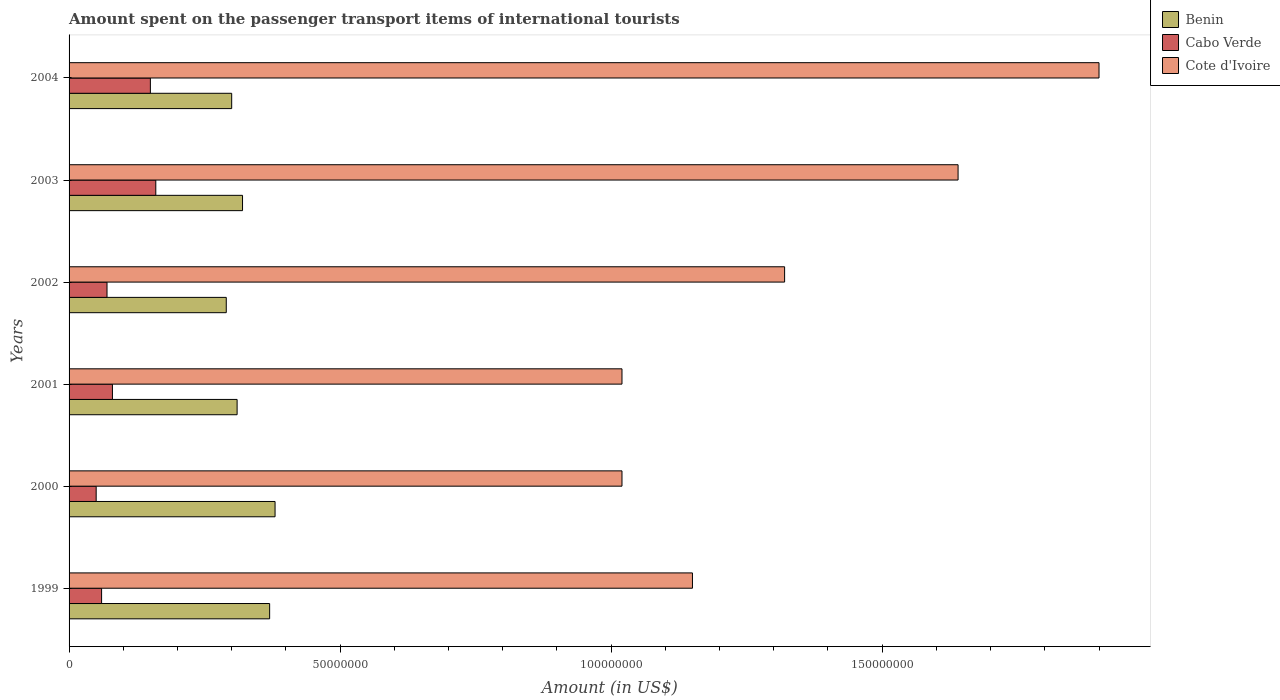Are the number of bars on each tick of the Y-axis equal?
Your answer should be compact. Yes. How many bars are there on the 4th tick from the top?
Provide a succinct answer. 3. What is the label of the 3rd group of bars from the top?
Your answer should be compact. 2002. What is the amount spent on the passenger transport items of international tourists in Cabo Verde in 2003?
Offer a terse response. 1.60e+07. Across all years, what is the maximum amount spent on the passenger transport items of international tourists in Cote d'Ivoire?
Give a very brief answer. 1.90e+08. Across all years, what is the minimum amount spent on the passenger transport items of international tourists in Cote d'Ivoire?
Provide a short and direct response. 1.02e+08. What is the total amount spent on the passenger transport items of international tourists in Cote d'Ivoire in the graph?
Your answer should be very brief. 8.05e+08. What is the difference between the amount spent on the passenger transport items of international tourists in Cabo Verde in 2002 and that in 2004?
Make the answer very short. -8.00e+06. What is the difference between the amount spent on the passenger transport items of international tourists in Cote d'Ivoire in 1999 and the amount spent on the passenger transport items of international tourists in Benin in 2003?
Offer a very short reply. 8.30e+07. What is the average amount spent on the passenger transport items of international tourists in Cote d'Ivoire per year?
Give a very brief answer. 1.34e+08. In the year 2000, what is the difference between the amount spent on the passenger transport items of international tourists in Benin and amount spent on the passenger transport items of international tourists in Cote d'Ivoire?
Keep it short and to the point. -6.40e+07. What is the ratio of the amount spent on the passenger transport items of international tourists in Cote d'Ivoire in 2001 to that in 2002?
Give a very brief answer. 0.77. Is the difference between the amount spent on the passenger transport items of international tourists in Benin in 2002 and 2003 greater than the difference between the amount spent on the passenger transport items of international tourists in Cote d'Ivoire in 2002 and 2003?
Keep it short and to the point. Yes. What is the difference between the highest and the lowest amount spent on the passenger transport items of international tourists in Cabo Verde?
Offer a terse response. 1.10e+07. What does the 2nd bar from the top in 1999 represents?
Ensure brevity in your answer.  Cabo Verde. What does the 3rd bar from the bottom in 2001 represents?
Make the answer very short. Cote d'Ivoire. How many bars are there?
Keep it short and to the point. 18. Are all the bars in the graph horizontal?
Offer a terse response. Yes. Are the values on the major ticks of X-axis written in scientific E-notation?
Your answer should be very brief. No. Where does the legend appear in the graph?
Keep it short and to the point. Top right. How many legend labels are there?
Make the answer very short. 3. What is the title of the graph?
Provide a succinct answer. Amount spent on the passenger transport items of international tourists. What is the label or title of the Y-axis?
Give a very brief answer. Years. What is the Amount (in US$) in Benin in 1999?
Provide a short and direct response. 3.70e+07. What is the Amount (in US$) of Cote d'Ivoire in 1999?
Your answer should be compact. 1.15e+08. What is the Amount (in US$) in Benin in 2000?
Make the answer very short. 3.80e+07. What is the Amount (in US$) in Cabo Verde in 2000?
Ensure brevity in your answer.  5.00e+06. What is the Amount (in US$) of Cote d'Ivoire in 2000?
Your answer should be compact. 1.02e+08. What is the Amount (in US$) in Benin in 2001?
Provide a short and direct response. 3.10e+07. What is the Amount (in US$) in Cabo Verde in 2001?
Make the answer very short. 8.00e+06. What is the Amount (in US$) in Cote d'Ivoire in 2001?
Make the answer very short. 1.02e+08. What is the Amount (in US$) of Benin in 2002?
Your answer should be compact. 2.90e+07. What is the Amount (in US$) in Cabo Verde in 2002?
Your response must be concise. 7.00e+06. What is the Amount (in US$) in Cote d'Ivoire in 2002?
Provide a short and direct response. 1.32e+08. What is the Amount (in US$) of Benin in 2003?
Give a very brief answer. 3.20e+07. What is the Amount (in US$) in Cabo Verde in 2003?
Provide a succinct answer. 1.60e+07. What is the Amount (in US$) of Cote d'Ivoire in 2003?
Offer a terse response. 1.64e+08. What is the Amount (in US$) of Benin in 2004?
Offer a very short reply. 3.00e+07. What is the Amount (in US$) of Cabo Verde in 2004?
Offer a very short reply. 1.50e+07. What is the Amount (in US$) in Cote d'Ivoire in 2004?
Your response must be concise. 1.90e+08. Across all years, what is the maximum Amount (in US$) in Benin?
Provide a succinct answer. 3.80e+07. Across all years, what is the maximum Amount (in US$) in Cabo Verde?
Ensure brevity in your answer.  1.60e+07. Across all years, what is the maximum Amount (in US$) of Cote d'Ivoire?
Make the answer very short. 1.90e+08. Across all years, what is the minimum Amount (in US$) of Benin?
Offer a very short reply. 2.90e+07. Across all years, what is the minimum Amount (in US$) in Cote d'Ivoire?
Your response must be concise. 1.02e+08. What is the total Amount (in US$) in Benin in the graph?
Make the answer very short. 1.97e+08. What is the total Amount (in US$) in Cabo Verde in the graph?
Keep it short and to the point. 5.70e+07. What is the total Amount (in US$) of Cote d'Ivoire in the graph?
Keep it short and to the point. 8.05e+08. What is the difference between the Amount (in US$) of Cote d'Ivoire in 1999 and that in 2000?
Provide a succinct answer. 1.30e+07. What is the difference between the Amount (in US$) of Cote d'Ivoire in 1999 and that in 2001?
Your answer should be compact. 1.30e+07. What is the difference between the Amount (in US$) of Benin in 1999 and that in 2002?
Your answer should be compact. 8.00e+06. What is the difference between the Amount (in US$) of Cabo Verde in 1999 and that in 2002?
Provide a succinct answer. -1.00e+06. What is the difference between the Amount (in US$) in Cote d'Ivoire in 1999 and that in 2002?
Your response must be concise. -1.70e+07. What is the difference between the Amount (in US$) of Cabo Verde in 1999 and that in 2003?
Ensure brevity in your answer.  -1.00e+07. What is the difference between the Amount (in US$) of Cote d'Ivoire in 1999 and that in 2003?
Give a very brief answer. -4.90e+07. What is the difference between the Amount (in US$) in Benin in 1999 and that in 2004?
Your response must be concise. 7.00e+06. What is the difference between the Amount (in US$) in Cabo Verde in 1999 and that in 2004?
Offer a terse response. -9.00e+06. What is the difference between the Amount (in US$) in Cote d'Ivoire in 1999 and that in 2004?
Provide a succinct answer. -7.50e+07. What is the difference between the Amount (in US$) of Cabo Verde in 2000 and that in 2001?
Your answer should be compact. -3.00e+06. What is the difference between the Amount (in US$) of Cote d'Ivoire in 2000 and that in 2001?
Provide a short and direct response. 0. What is the difference between the Amount (in US$) in Benin in 2000 and that in 2002?
Offer a terse response. 9.00e+06. What is the difference between the Amount (in US$) of Cabo Verde in 2000 and that in 2002?
Make the answer very short. -2.00e+06. What is the difference between the Amount (in US$) in Cote d'Ivoire in 2000 and that in 2002?
Give a very brief answer. -3.00e+07. What is the difference between the Amount (in US$) of Cabo Verde in 2000 and that in 2003?
Provide a succinct answer. -1.10e+07. What is the difference between the Amount (in US$) in Cote d'Ivoire in 2000 and that in 2003?
Offer a very short reply. -6.20e+07. What is the difference between the Amount (in US$) of Benin in 2000 and that in 2004?
Your answer should be compact. 8.00e+06. What is the difference between the Amount (in US$) in Cabo Verde in 2000 and that in 2004?
Offer a very short reply. -1.00e+07. What is the difference between the Amount (in US$) in Cote d'Ivoire in 2000 and that in 2004?
Your answer should be compact. -8.80e+07. What is the difference between the Amount (in US$) in Cote d'Ivoire in 2001 and that in 2002?
Make the answer very short. -3.00e+07. What is the difference between the Amount (in US$) in Cabo Verde in 2001 and that in 2003?
Offer a very short reply. -8.00e+06. What is the difference between the Amount (in US$) of Cote d'Ivoire in 2001 and that in 2003?
Give a very brief answer. -6.20e+07. What is the difference between the Amount (in US$) of Cabo Verde in 2001 and that in 2004?
Give a very brief answer. -7.00e+06. What is the difference between the Amount (in US$) in Cote d'Ivoire in 2001 and that in 2004?
Make the answer very short. -8.80e+07. What is the difference between the Amount (in US$) in Cabo Verde in 2002 and that in 2003?
Provide a succinct answer. -9.00e+06. What is the difference between the Amount (in US$) in Cote d'Ivoire in 2002 and that in 2003?
Offer a very short reply. -3.20e+07. What is the difference between the Amount (in US$) of Cabo Verde in 2002 and that in 2004?
Ensure brevity in your answer.  -8.00e+06. What is the difference between the Amount (in US$) of Cote d'Ivoire in 2002 and that in 2004?
Your answer should be compact. -5.80e+07. What is the difference between the Amount (in US$) of Benin in 2003 and that in 2004?
Your response must be concise. 2.00e+06. What is the difference between the Amount (in US$) in Cabo Verde in 2003 and that in 2004?
Ensure brevity in your answer.  1.00e+06. What is the difference between the Amount (in US$) in Cote d'Ivoire in 2003 and that in 2004?
Ensure brevity in your answer.  -2.60e+07. What is the difference between the Amount (in US$) of Benin in 1999 and the Amount (in US$) of Cabo Verde in 2000?
Your response must be concise. 3.20e+07. What is the difference between the Amount (in US$) of Benin in 1999 and the Amount (in US$) of Cote d'Ivoire in 2000?
Your response must be concise. -6.50e+07. What is the difference between the Amount (in US$) of Cabo Verde in 1999 and the Amount (in US$) of Cote d'Ivoire in 2000?
Offer a very short reply. -9.60e+07. What is the difference between the Amount (in US$) in Benin in 1999 and the Amount (in US$) in Cabo Verde in 2001?
Your answer should be compact. 2.90e+07. What is the difference between the Amount (in US$) of Benin in 1999 and the Amount (in US$) of Cote d'Ivoire in 2001?
Your answer should be compact. -6.50e+07. What is the difference between the Amount (in US$) of Cabo Verde in 1999 and the Amount (in US$) of Cote d'Ivoire in 2001?
Your answer should be very brief. -9.60e+07. What is the difference between the Amount (in US$) of Benin in 1999 and the Amount (in US$) of Cabo Verde in 2002?
Keep it short and to the point. 3.00e+07. What is the difference between the Amount (in US$) in Benin in 1999 and the Amount (in US$) in Cote d'Ivoire in 2002?
Provide a succinct answer. -9.50e+07. What is the difference between the Amount (in US$) in Cabo Verde in 1999 and the Amount (in US$) in Cote d'Ivoire in 2002?
Give a very brief answer. -1.26e+08. What is the difference between the Amount (in US$) in Benin in 1999 and the Amount (in US$) in Cabo Verde in 2003?
Offer a terse response. 2.10e+07. What is the difference between the Amount (in US$) of Benin in 1999 and the Amount (in US$) of Cote d'Ivoire in 2003?
Provide a succinct answer. -1.27e+08. What is the difference between the Amount (in US$) of Cabo Verde in 1999 and the Amount (in US$) of Cote d'Ivoire in 2003?
Your answer should be very brief. -1.58e+08. What is the difference between the Amount (in US$) in Benin in 1999 and the Amount (in US$) in Cabo Verde in 2004?
Give a very brief answer. 2.20e+07. What is the difference between the Amount (in US$) of Benin in 1999 and the Amount (in US$) of Cote d'Ivoire in 2004?
Ensure brevity in your answer.  -1.53e+08. What is the difference between the Amount (in US$) of Cabo Verde in 1999 and the Amount (in US$) of Cote d'Ivoire in 2004?
Provide a short and direct response. -1.84e+08. What is the difference between the Amount (in US$) in Benin in 2000 and the Amount (in US$) in Cabo Verde in 2001?
Make the answer very short. 3.00e+07. What is the difference between the Amount (in US$) in Benin in 2000 and the Amount (in US$) in Cote d'Ivoire in 2001?
Your response must be concise. -6.40e+07. What is the difference between the Amount (in US$) in Cabo Verde in 2000 and the Amount (in US$) in Cote d'Ivoire in 2001?
Your answer should be compact. -9.70e+07. What is the difference between the Amount (in US$) in Benin in 2000 and the Amount (in US$) in Cabo Verde in 2002?
Your response must be concise. 3.10e+07. What is the difference between the Amount (in US$) in Benin in 2000 and the Amount (in US$) in Cote d'Ivoire in 2002?
Your answer should be compact. -9.40e+07. What is the difference between the Amount (in US$) of Cabo Verde in 2000 and the Amount (in US$) of Cote d'Ivoire in 2002?
Give a very brief answer. -1.27e+08. What is the difference between the Amount (in US$) in Benin in 2000 and the Amount (in US$) in Cabo Verde in 2003?
Make the answer very short. 2.20e+07. What is the difference between the Amount (in US$) of Benin in 2000 and the Amount (in US$) of Cote d'Ivoire in 2003?
Provide a short and direct response. -1.26e+08. What is the difference between the Amount (in US$) of Cabo Verde in 2000 and the Amount (in US$) of Cote d'Ivoire in 2003?
Your answer should be compact. -1.59e+08. What is the difference between the Amount (in US$) of Benin in 2000 and the Amount (in US$) of Cabo Verde in 2004?
Offer a very short reply. 2.30e+07. What is the difference between the Amount (in US$) of Benin in 2000 and the Amount (in US$) of Cote d'Ivoire in 2004?
Provide a short and direct response. -1.52e+08. What is the difference between the Amount (in US$) in Cabo Verde in 2000 and the Amount (in US$) in Cote d'Ivoire in 2004?
Your answer should be compact. -1.85e+08. What is the difference between the Amount (in US$) of Benin in 2001 and the Amount (in US$) of Cabo Verde in 2002?
Give a very brief answer. 2.40e+07. What is the difference between the Amount (in US$) in Benin in 2001 and the Amount (in US$) in Cote d'Ivoire in 2002?
Ensure brevity in your answer.  -1.01e+08. What is the difference between the Amount (in US$) of Cabo Verde in 2001 and the Amount (in US$) of Cote d'Ivoire in 2002?
Your answer should be compact. -1.24e+08. What is the difference between the Amount (in US$) of Benin in 2001 and the Amount (in US$) of Cabo Verde in 2003?
Offer a terse response. 1.50e+07. What is the difference between the Amount (in US$) of Benin in 2001 and the Amount (in US$) of Cote d'Ivoire in 2003?
Offer a very short reply. -1.33e+08. What is the difference between the Amount (in US$) in Cabo Verde in 2001 and the Amount (in US$) in Cote d'Ivoire in 2003?
Your response must be concise. -1.56e+08. What is the difference between the Amount (in US$) of Benin in 2001 and the Amount (in US$) of Cabo Verde in 2004?
Ensure brevity in your answer.  1.60e+07. What is the difference between the Amount (in US$) in Benin in 2001 and the Amount (in US$) in Cote d'Ivoire in 2004?
Offer a terse response. -1.59e+08. What is the difference between the Amount (in US$) of Cabo Verde in 2001 and the Amount (in US$) of Cote d'Ivoire in 2004?
Make the answer very short. -1.82e+08. What is the difference between the Amount (in US$) of Benin in 2002 and the Amount (in US$) of Cabo Verde in 2003?
Ensure brevity in your answer.  1.30e+07. What is the difference between the Amount (in US$) in Benin in 2002 and the Amount (in US$) in Cote d'Ivoire in 2003?
Ensure brevity in your answer.  -1.35e+08. What is the difference between the Amount (in US$) of Cabo Verde in 2002 and the Amount (in US$) of Cote d'Ivoire in 2003?
Your answer should be very brief. -1.57e+08. What is the difference between the Amount (in US$) in Benin in 2002 and the Amount (in US$) in Cabo Verde in 2004?
Give a very brief answer. 1.40e+07. What is the difference between the Amount (in US$) in Benin in 2002 and the Amount (in US$) in Cote d'Ivoire in 2004?
Offer a terse response. -1.61e+08. What is the difference between the Amount (in US$) of Cabo Verde in 2002 and the Amount (in US$) of Cote d'Ivoire in 2004?
Your answer should be very brief. -1.83e+08. What is the difference between the Amount (in US$) in Benin in 2003 and the Amount (in US$) in Cabo Verde in 2004?
Your answer should be compact. 1.70e+07. What is the difference between the Amount (in US$) in Benin in 2003 and the Amount (in US$) in Cote d'Ivoire in 2004?
Provide a short and direct response. -1.58e+08. What is the difference between the Amount (in US$) in Cabo Verde in 2003 and the Amount (in US$) in Cote d'Ivoire in 2004?
Make the answer very short. -1.74e+08. What is the average Amount (in US$) of Benin per year?
Your answer should be compact. 3.28e+07. What is the average Amount (in US$) of Cabo Verde per year?
Offer a very short reply. 9.50e+06. What is the average Amount (in US$) of Cote d'Ivoire per year?
Make the answer very short. 1.34e+08. In the year 1999, what is the difference between the Amount (in US$) in Benin and Amount (in US$) in Cabo Verde?
Your answer should be compact. 3.10e+07. In the year 1999, what is the difference between the Amount (in US$) in Benin and Amount (in US$) in Cote d'Ivoire?
Your answer should be very brief. -7.80e+07. In the year 1999, what is the difference between the Amount (in US$) of Cabo Verde and Amount (in US$) of Cote d'Ivoire?
Provide a succinct answer. -1.09e+08. In the year 2000, what is the difference between the Amount (in US$) of Benin and Amount (in US$) of Cabo Verde?
Your response must be concise. 3.30e+07. In the year 2000, what is the difference between the Amount (in US$) of Benin and Amount (in US$) of Cote d'Ivoire?
Offer a terse response. -6.40e+07. In the year 2000, what is the difference between the Amount (in US$) in Cabo Verde and Amount (in US$) in Cote d'Ivoire?
Provide a short and direct response. -9.70e+07. In the year 2001, what is the difference between the Amount (in US$) of Benin and Amount (in US$) of Cabo Verde?
Your response must be concise. 2.30e+07. In the year 2001, what is the difference between the Amount (in US$) in Benin and Amount (in US$) in Cote d'Ivoire?
Your response must be concise. -7.10e+07. In the year 2001, what is the difference between the Amount (in US$) in Cabo Verde and Amount (in US$) in Cote d'Ivoire?
Your answer should be compact. -9.40e+07. In the year 2002, what is the difference between the Amount (in US$) of Benin and Amount (in US$) of Cabo Verde?
Offer a very short reply. 2.20e+07. In the year 2002, what is the difference between the Amount (in US$) in Benin and Amount (in US$) in Cote d'Ivoire?
Your response must be concise. -1.03e+08. In the year 2002, what is the difference between the Amount (in US$) in Cabo Verde and Amount (in US$) in Cote d'Ivoire?
Provide a short and direct response. -1.25e+08. In the year 2003, what is the difference between the Amount (in US$) of Benin and Amount (in US$) of Cabo Verde?
Keep it short and to the point. 1.60e+07. In the year 2003, what is the difference between the Amount (in US$) in Benin and Amount (in US$) in Cote d'Ivoire?
Ensure brevity in your answer.  -1.32e+08. In the year 2003, what is the difference between the Amount (in US$) of Cabo Verde and Amount (in US$) of Cote d'Ivoire?
Offer a terse response. -1.48e+08. In the year 2004, what is the difference between the Amount (in US$) of Benin and Amount (in US$) of Cabo Verde?
Keep it short and to the point. 1.50e+07. In the year 2004, what is the difference between the Amount (in US$) in Benin and Amount (in US$) in Cote d'Ivoire?
Your answer should be compact. -1.60e+08. In the year 2004, what is the difference between the Amount (in US$) of Cabo Verde and Amount (in US$) of Cote d'Ivoire?
Give a very brief answer. -1.75e+08. What is the ratio of the Amount (in US$) of Benin in 1999 to that in 2000?
Your answer should be very brief. 0.97. What is the ratio of the Amount (in US$) in Cote d'Ivoire in 1999 to that in 2000?
Provide a succinct answer. 1.13. What is the ratio of the Amount (in US$) of Benin in 1999 to that in 2001?
Give a very brief answer. 1.19. What is the ratio of the Amount (in US$) in Cote d'Ivoire in 1999 to that in 2001?
Make the answer very short. 1.13. What is the ratio of the Amount (in US$) in Benin in 1999 to that in 2002?
Your response must be concise. 1.28. What is the ratio of the Amount (in US$) of Cote d'Ivoire in 1999 to that in 2002?
Your response must be concise. 0.87. What is the ratio of the Amount (in US$) in Benin in 1999 to that in 2003?
Provide a succinct answer. 1.16. What is the ratio of the Amount (in US$) in Cote d'Ivoire in 1999 to that in 2003?
Ensure brevity in your answer.  0.7. What is the ratio of the Amount (in US$) of Benin in 1999 to that in 2004?
Provide a short and direct response. 1.23. What is the ratio of the Amount (in US$) in Cabo Verde in 1999 to that in 2004?
Your answer should be compact. 0.4. What is the ratio of the Amount (in US$) in Cote d'Ivoire in 1999 to that in 2004?
Provide a short and direct response. 0.61. What is the ratio of the Amount (in US$) in Benin in 2000 to that in 2001?
Make the answer very short. 1.23. What is the ratio of the Amount (in US$) in Cote d'Ivoire in 2000 to that in 2001?
Your answer should be compact. 1. What is the ratio of the Amount (in US$) in Benin in 2000 to that in 2002?
Give a very brief answer. 1.31. What is the ratio of the Amount (in US$) in Cabo Verde in 2000 to that in 2002?
Keep it short and to the point. 0.71. What is the ratio of the Amount (in US$) in Cote d'Ivoire in 2000 to that in 2002?
Ensure brevity in your answer.  0.77. What is the ratio of the Amount (in US$) of Benin in 2000 to that in 2003?
Make the answer very short. 1.19. What is the ratio of the Amount (in US$) in Cabo Verde in 2000 to that in 2003?
Offer a terse response. 0.31. What is the ratio of the Amount (in US$) in Cote d'Ivoire in 2000 to that in 2003?
Provide a succinct answer. 0.62. What is the ratio of the Amount (in US$) of Benin in 2000 to that in 2004?
Give a very brief answer. 1.27. What is the ratio of the Amount (in US$) of Cote d'Ivoire in 2000 to that in 2004?
Give a very brief answer. 0.54. What is the ratio of the Amount (in US$) of Benin in 2001 to that in 2002?
Offer a very short reply. 1.07. What is the ratio of the Amount (in US$) of Cote d'Ivoire in 2001 to that in 2002?
Give a very brief answer. 0.77. What is the ratio of the Amount (in US$) in Benin in 2001 to that in 2003?
Make the answer very short. 0.97. What is the ratio of the Amount (in US$) in Cabo Verde in 2001 to that in 2003?
Keep it short and to the point. 0.5. What is the ratio of the Amount (in US$) in Cote d'Ivoire in 2001 to that in 2003?
Offer a terse response. 0.62. What is the ratio of the Amount (in US$) in Benin in 2001 to that in 2004?
Your answer should be very brief. 1.03. What is the ratio of the Amount (in US$) of Cabo Verde in 2001 to that in 2004?
Make the answer very short. 0.53. What is the ratio of the Amount (in US$) in Cote d'Ivoire in 2001 to that in 2004?
Keep it short and to the point. 0.54. What is the ratio of the Amount (in US$) in Benin in 2002 to that in 2003?
Offer a terse response. 0.91. What is the ratio of the Amount (in US$) in Cabo Verde in 2002 to that in 2003?
Your answer should be very brief. 0.44. What is the ratio of the Amount (in US$) in Cote d'Ivoire in 2002 to that in 2003?
Provide a short and direct response. 0.8. What is the ratio of the Amount (in US$) in Benin in 2002 to that in 2004?
Your answer should be very brief. 0.97. What is the ratio of the Amount (in US$) in Cabo Verde in 2002 to that in 2004?
Provide a short and direct response. 0.47. What is the ratio of the Amount (in US$) of Cote d'Ivoire in 2002 to that in 2004?
Your response must be concise. 0.69. What is the ratio of the Amount (in US$) in Benin in 2003 to that in 2004?
Your answer should be very brief. 1.07. What is the ratio of the Amount (in US$) in Cabo Verde in 2003 to that in 2004?
Provide a succinct answer. 1.07. What is the ratio of the Amount (in US$) of Cote d'Ivoire in 2003 to that in 2004?
Your answer should be very brief. 0.86. What is the difference between the highest and the second highest Amount (in US$) of Cabo Verde?
Ensure brevity in your answer.  1.00e+06. What is the difference between the highest and the second highest Amount (in US$) of Cote d'Ivoire?
Give a very brief answer. 2.60e+07. What is the difference between the highest and the lowest Amount (in US$) in Benin?
Keep it short and to the point. 9.00e+06. What is the difference between the highest and the lowest Amount (in US$) in Cabo Verde?
Provide a succinct answer. 1.10e+07. What is the difference between the highest and the lowest Amount (in US$) in Cote d'Ivoire?
Your answer should be very brief. 8.80e+07. 